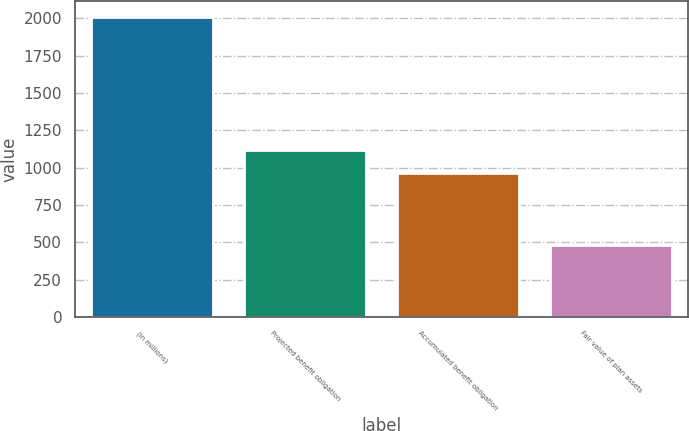Convert chart to OTSL. <chart><loc_0><loc_0><loc_500><loc_500><bar_chart><fcel>(in millions)<fcel>Projected benefit obligation<fcel>Accumulated benefit obligation<fcel>Fair value of plan assets<nl><fcel>2012<fcel>1116.7<fcel>964<fcel>485<nl></chart> 